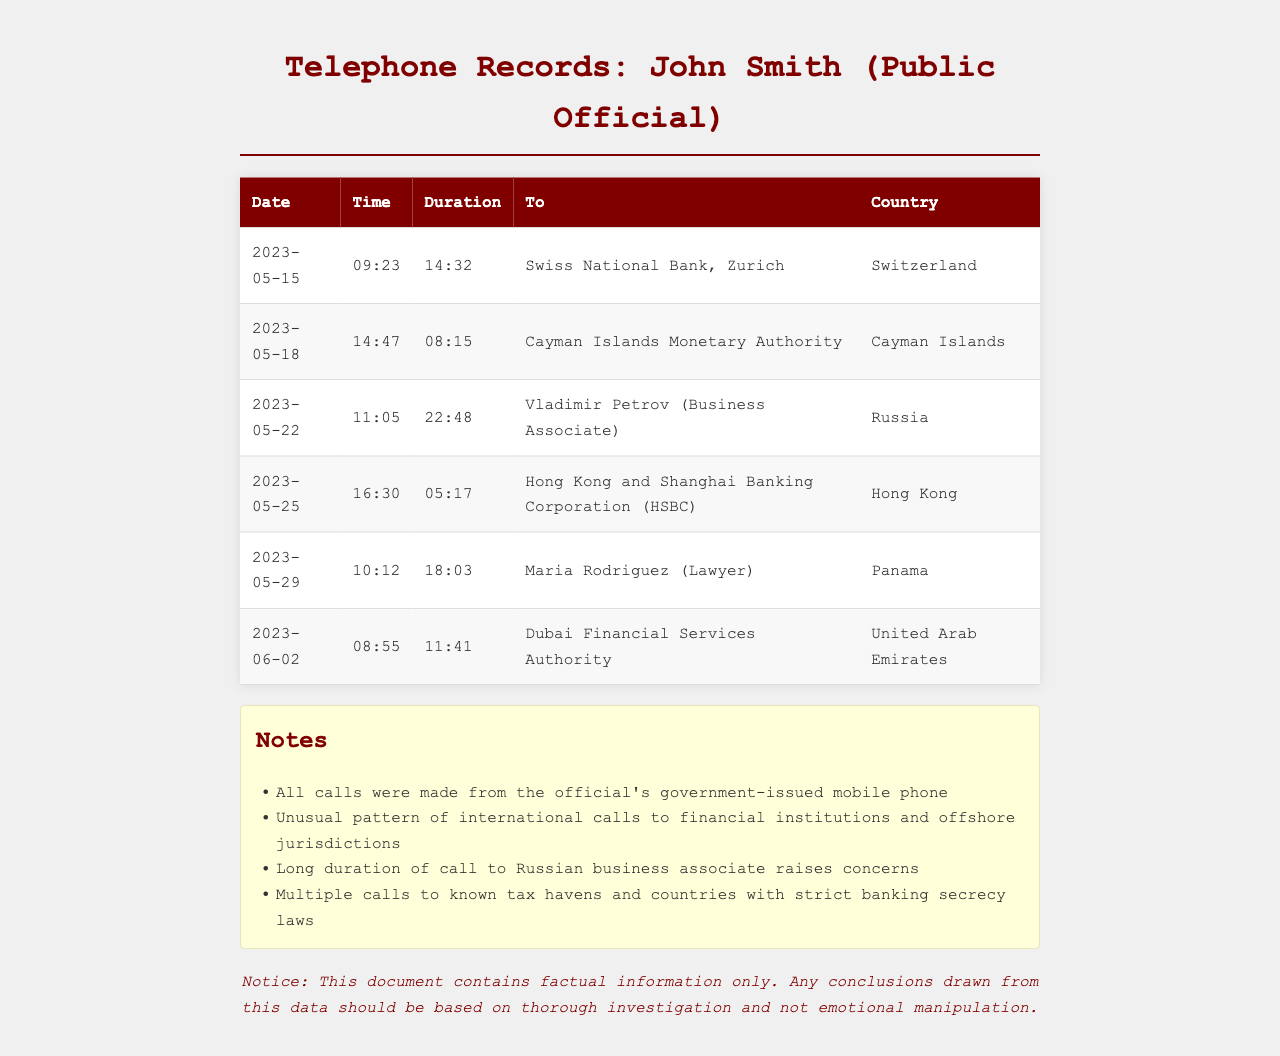What is the date of the longest call? The longest call is noted in the records on May 22, lasting 22:48.
Answer: 2023-05-22 What organization was contacted on May 15? The organization called on May 15 was the Swiss National Bank in Zurich.
Answer: Swiss National Bank, Zurich How many calls were made to financial institutions? There are four calls made to financial institutions listed in the document.
Answer: 4 What was the duration of the call to the Cayman Islands Monetary Authority? The call duration to the Cayman Islands Monetary Authority was 08:15.
Answer: 08:15 Which country is associated with Maria Rodriguez? Maria Rodriguez is associated with Panama.
Answer: Panama What is the common theme of the calls made by John Smith? The calls show an unusual pattern to financial institutions and offshore jurisdictions.
Answer: Financial institutions and offshore jurisdictions How many calls were made to known tax havens? There are three calls made to known tax havens in the records.
Answer: 3 What type of phone was used to make the calls? The calls were made from the official's government-issued mobile phone.
Answer: Government-issued mobile phone 